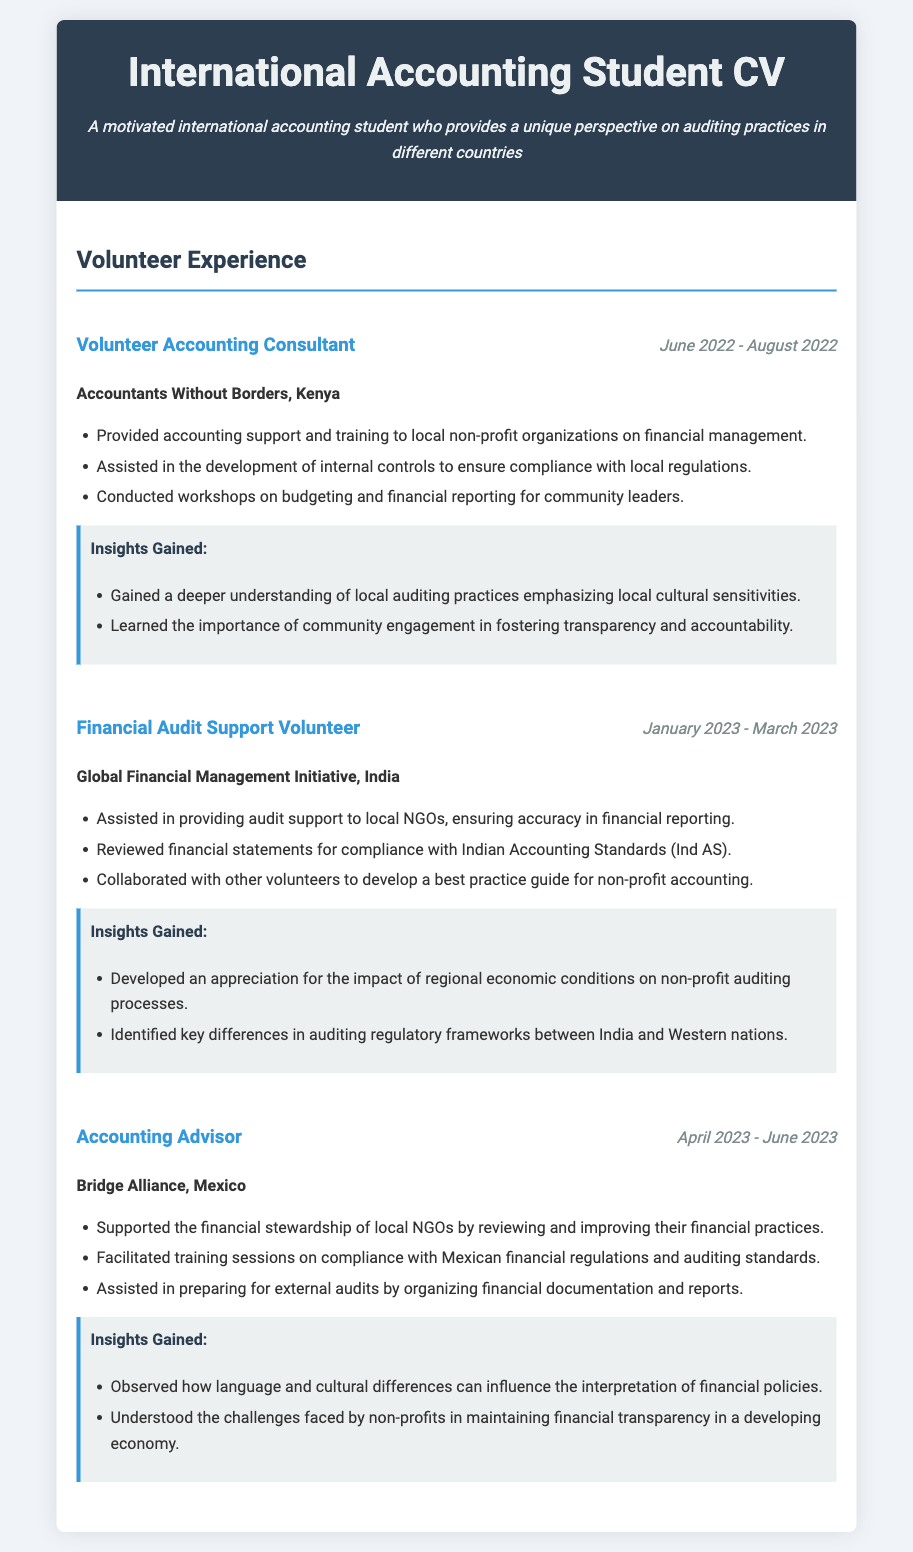What organization did the volunteer accounting consultant work with? The document states that the volunteer accounting consultant worked with "Accountants Without Borders."
Answer: Accountants Without Borders When did the financial audit support volunteering take place? The duration mentioned in the document for financial audit support volunteering is from January 2023 to March 2023.
Answer: January 2023 - March 2023 What was one of the responsibilities of the Accounting Advisor in Mexico? The responsibilities listed in the document include reviewing and improving financial practices of local NGOs.
Answer: Reviewing and improving financial practices List one insight gained from volunteering in Kenya. The document mentions insights like a deeper understanding of local auditing practices.
Answer: Deeper understanding of local auditing practices What key difference was identified in the auditing regulatory frameworks? The document states that key differences were identified between India and Western nations.
Answer: Between India and Western nations What type of organization is the Global Financial Management Initiative? Based on the document, this organization works to support local NGOs through audit assistance.
Answer: Local NGOs How long was the role of Accounting Advisor held in Mexico? The document indicates the duration of the Accounting Advisor role was from April 2023 to June 2023.
Answer: April 2023 - June 2023 What aspect of local culture influenced financial policies in Mexico? The document indicates that language and cultural differences can influence the interpretation of financial policies.
Answer: Language and cultural differences What was a primary focus during the workshops conducted in Kenya? The document states that workshops focused on budgeting and financial reporting for community leaders.
Answer: Budgeting and financial reporting 